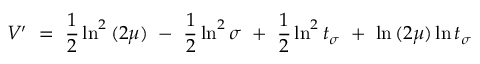Convert formula to latex. <formula><loc_0><loc_0><loc_500><loc_500>V { ^ { \prime } } = \frac { 1 } { 2 } \ln ^ { 2 } { ( 2 \mu ) } - \frac { 1 } { 2 } \ln ^ { 2 } { \sigma } + \frac { 1 } { 2 } \ln ^ { 2 } { t _ { \sigma } } + \ln { ( 2 \mu ) } \ln { t _ { \sigma } }</formula> 